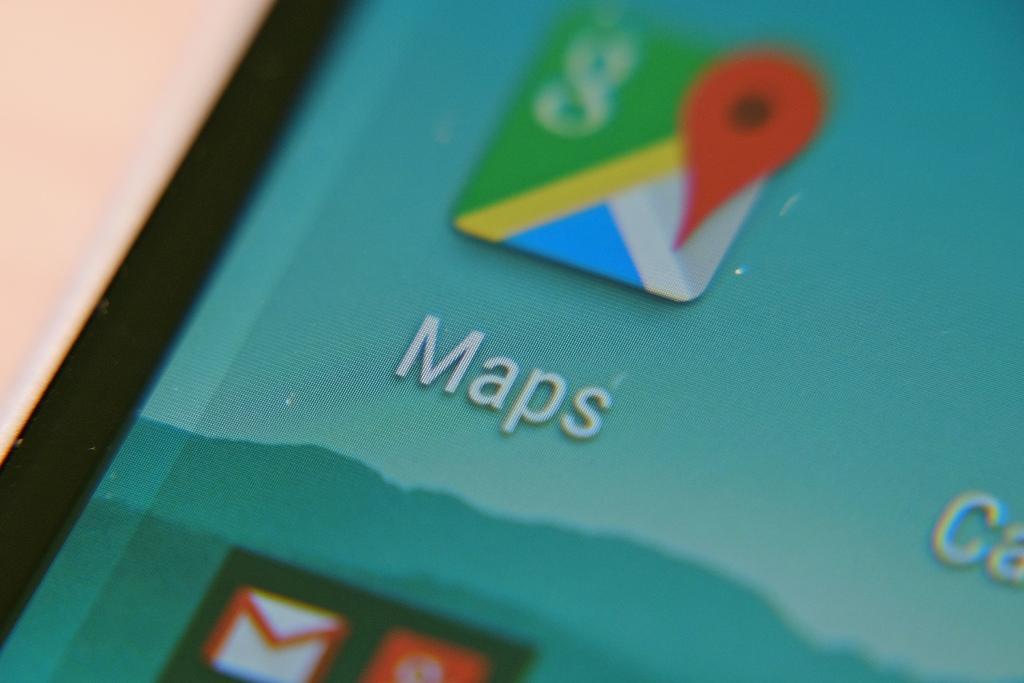What app is on the screen?
Offer a terse response. Maps. What letter is in the green box?
Your answer should be compact. G. 